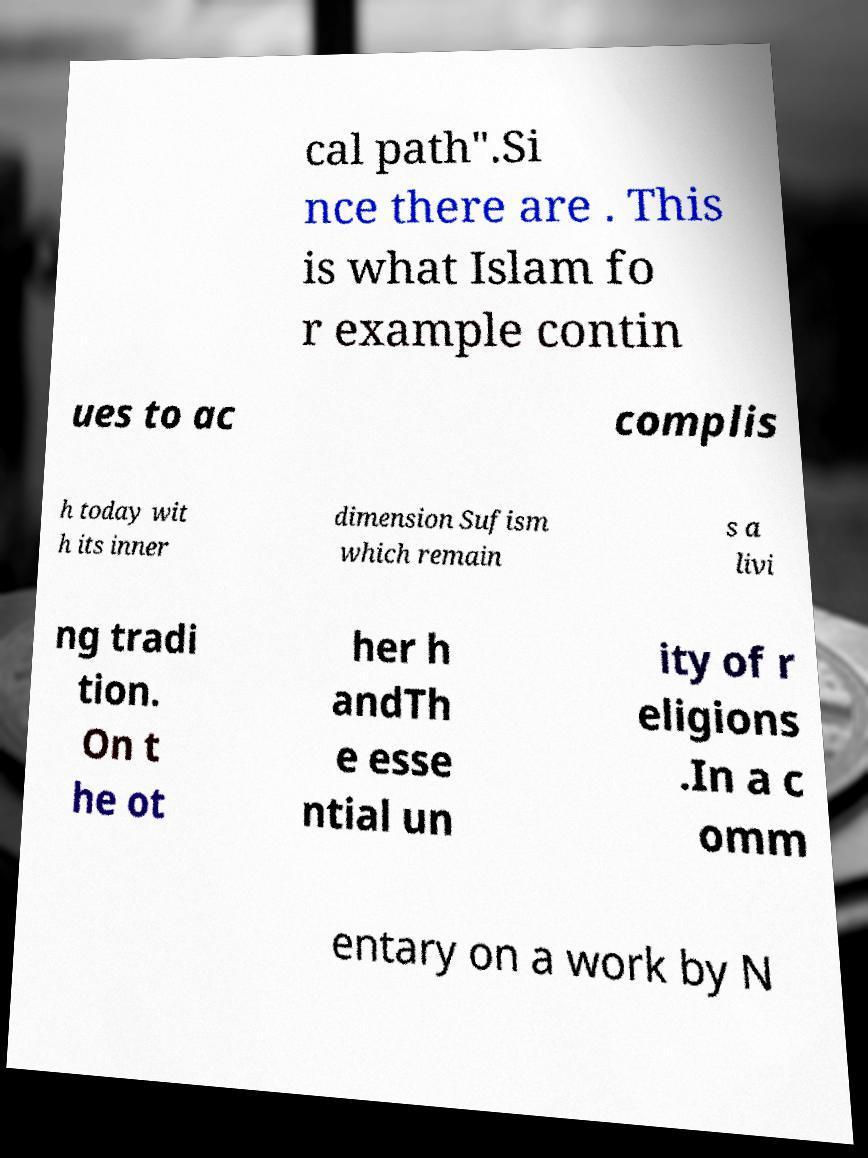For documentation purposes, I need the text within this image transcribed. Could you provide that? cal path".Si nce there are . This is what Islam fo r example contin ues to ac complis h today wit h its inner dimension Sufism which remain s a livi ng tradi tion. On t he ot her h andTh e esse ntial un ity of r eligions .In a c omm entary on a work by N 